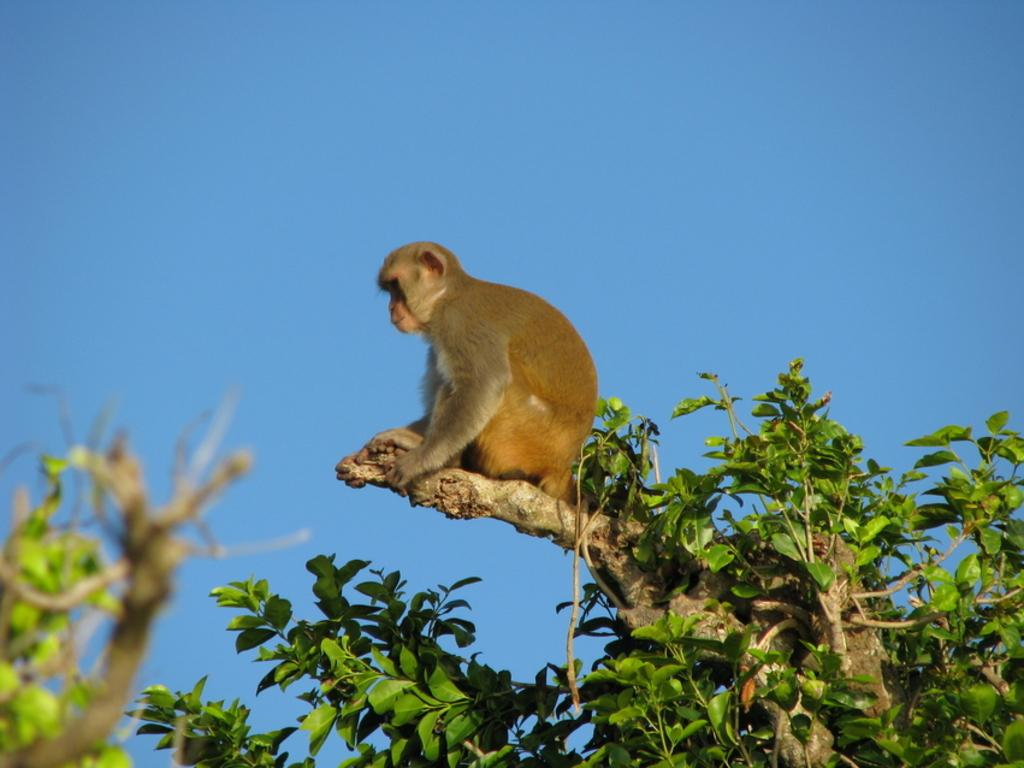What animal is present in the image? There is a monkey in the image. Where is the monkey located? The monkey is sitting on a tree. What can be seen at the top of the image? The sky is visible at the top of the image. What type of bottle is the monkey holding in the image? There is no bottle present in the image; the monkey is sitting on a tree. How does the monkey pull itself up the tree in the image? The image does not show the monkey pulling itself up the tree, only the monkey sitting on the tree. 